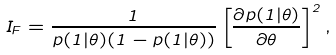Convert formula to latex. <formula><loc_0><loc_0><loc_500><loc_500>I _ { F } = \frac { 1 } { p ( 1 | \theta ) ( 1 - p ( 1 | \theta ) ) } \left [ \frac { \partial p ( 1 | \theta ) } { \partial \theta } \right ] ^ { 2 } ,</formula> 